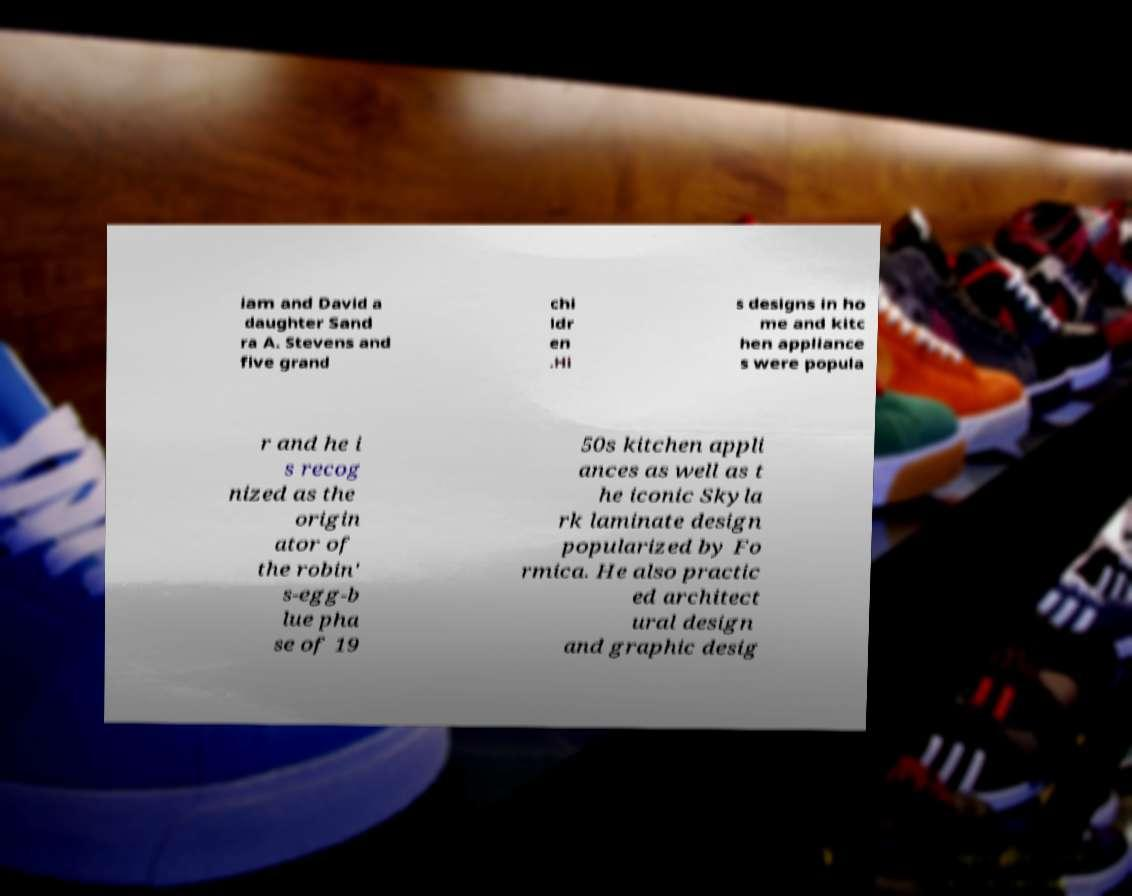Please read and relay the text visible in this image. What does it say? iam and David a daughter Sand ra A. Stevens and five grand chi ldr en .Hi s designs in ho me and kitc hen appliance s were popula r and he i s recog nized as the origin ator of the robin' s-egg-b lue pha se of 19 50s kitchen appli ances as well as t he iconic Skyla rk laminate design popularized by Fo rmica. He also practic ed architect ural design and graphic desig 